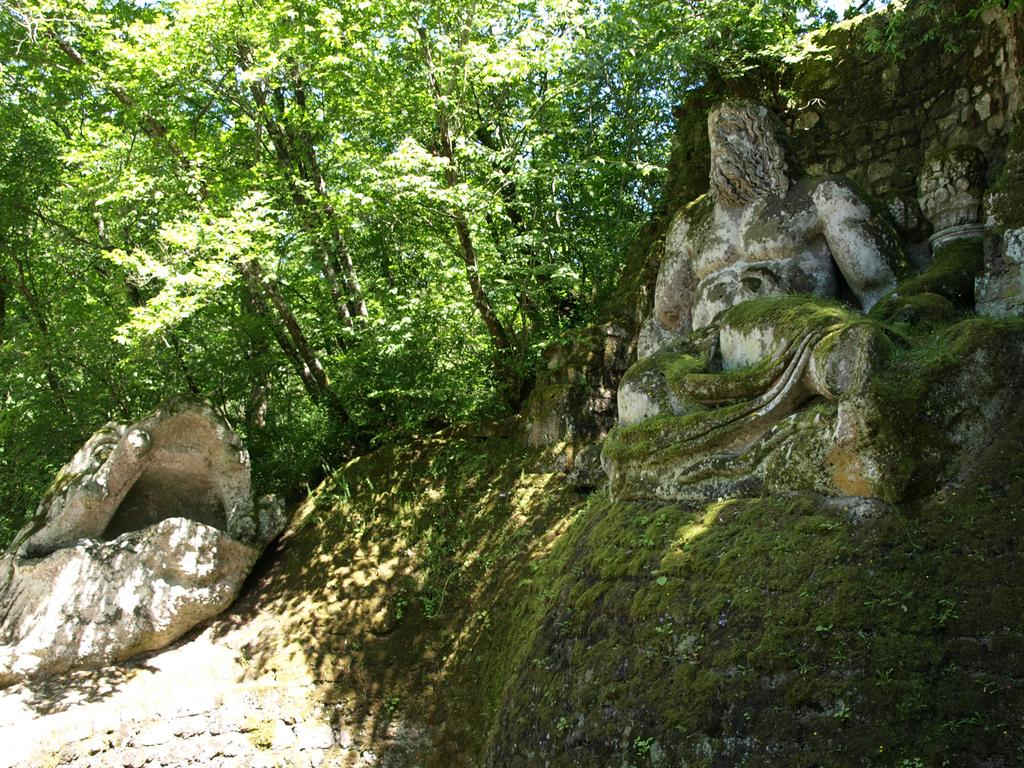What is the main subject in the foreground of the image? There is a sculpture in the foreground of the image. What type of terrain is visible in the foreground of the image? There is grassland in the foreground of the image. What can be seen in the background of the image? There are trees and stones in the background of the image. What type of milk is being poured over the sculpture in the image? There is no milk present in the image; it features a sculpture, grassland, trees, and stones. 